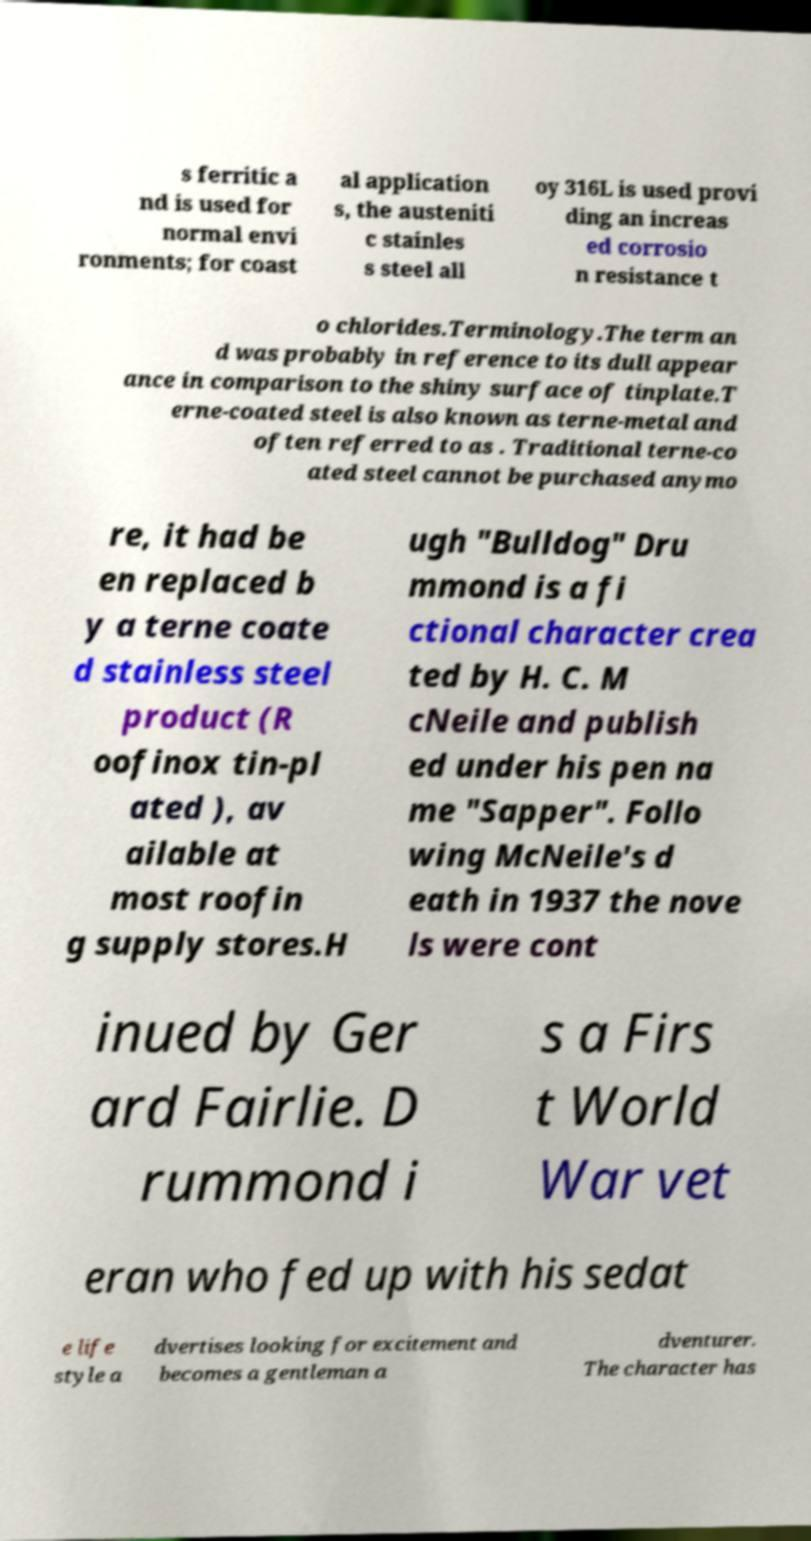I need the written content from this picture converted into text. Can you do that? s ferritic a nd is used for normal envi ronments; for coast al application s, the austeniti c stainles s steel all oy 316L is used provi ding an increas ed corrosio n resistance t o chlorides.Terminology.The term an d was probably in reference to its dull appear ance in comparison to the shiny surface of tinplate.T erne-coated steel is also known as terne-metal and often referred to as . Traditional terne-co ated steel cannot be purchased anymo re, it had be en replaced b y a terne coate d stainless steel product (R oofinox tin-pl ated ), av ailable at most roofin g supply stores.H ugh "Bulldog" Dru mmond is a fi ctional character crea ted by H. C. M cNeile and publish ed under his pen na me "Sapper". Follo wing McNeile's d eath in 1937 the nove ls were cont inued by Ger ard Fairlie. D rummond i s a Firs t World War vet eran who fed up with his sedat e life style a dvertises looking for excitement and becomes a gentleman a dventurer. The character has 